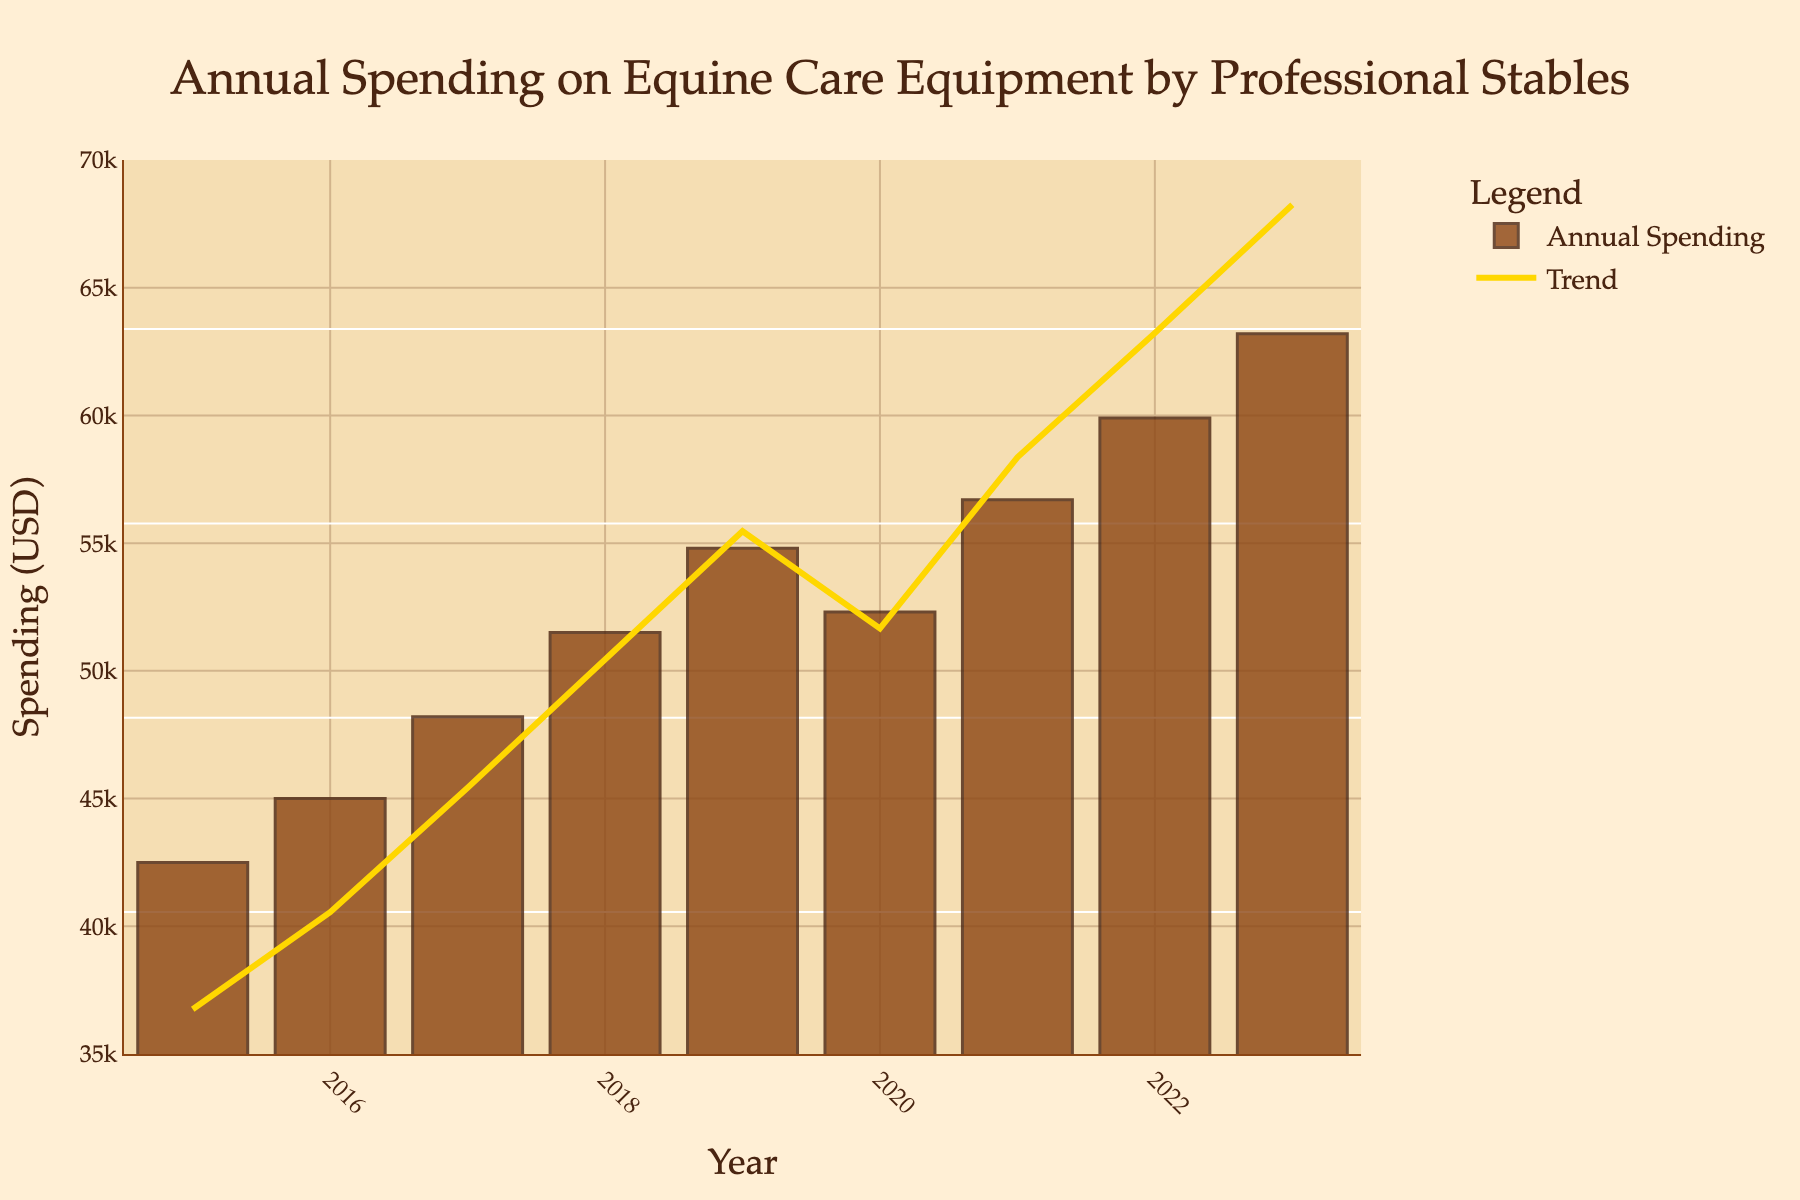Which year had the highest spending on equine care equipment? By observing the figure, the height of the bar in 2023 is the tallest compared to all other years. Therefore, the highest spending occurred in 2023.
Answer: 2023 Which year saw a decrease in spending compared to the previous year? The figure shows that spending decreases from 2019 to 2020. The height of the bar in 2020 is shorter than in 2019.
Answer: 2020 What is the total spending over all the years presented in the figure? Sum the spending values from each year: 42500 + 45000 + 48200 + 51500 + 54800 + 52300 + 56700 + 59900 + 63200 = 474100.
Answer: 474100 Compare the spending between 2018 and 2022. Which year had higher spending and by how much? The spending in 2018 was 51500, and in 2022 it was 59900. Subtract the spending in 2018 from that in 2022: 59900 - 51500 = 8400.
Answer: 2022, by 8400 What is the average annual spending on equine care equipment over the period shown? Sum the spending values and divide by the number of years: 474100 / 9 ≈ 52677.78.
Answer: 52677.78 How much did the spending increase from 2015 to 2023? Subtract the spending in 2015 from that in 2023: 63200 - 42500 = 20700.
Answer: 20700 What is the median annual spending over the years presented? List the spending values in ascending order and find the middle value: 42500, 45000, 48200, 51500, 52300, 54800, 56700, 59900, 63200. The middle value (5th) is 52300.
Answer: 52300 Between 2017 and 2023, which year had the lowest spending, and what was the amount? Among the bars from 2017 to 2023, the shortest bar is in 2017 with a spending of 48200.
Answer: 2017, 48200 